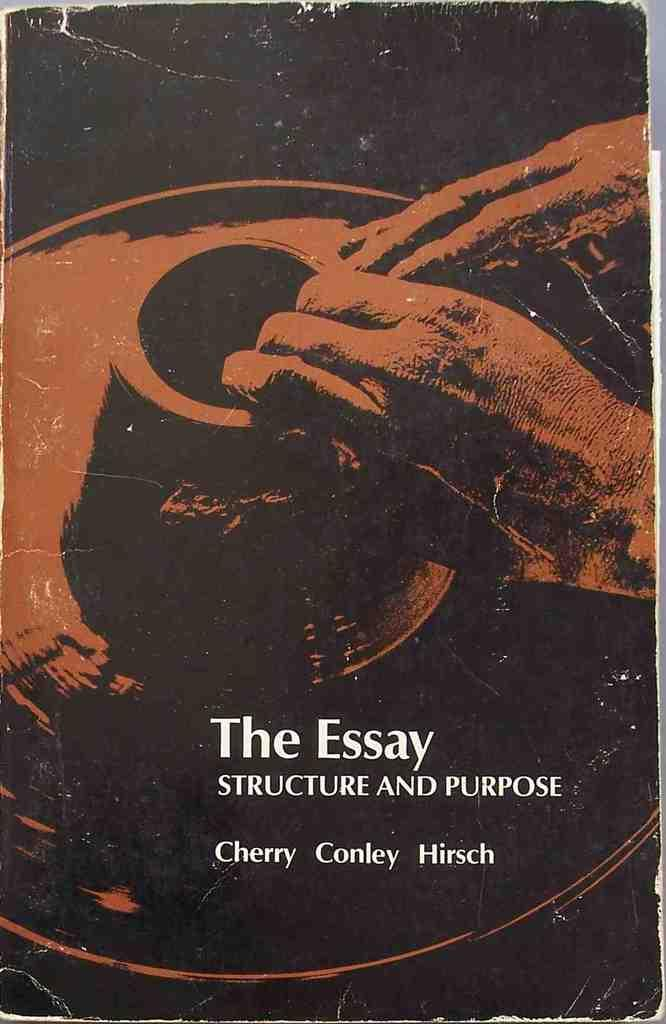<image>
Give a short and clear explanation of the subsequent image. A scan shows an image of hands molding a clay pot on the worn cover of a book called "The Essay Structure and Purpose" by Cherry Conley and Hirsch. 